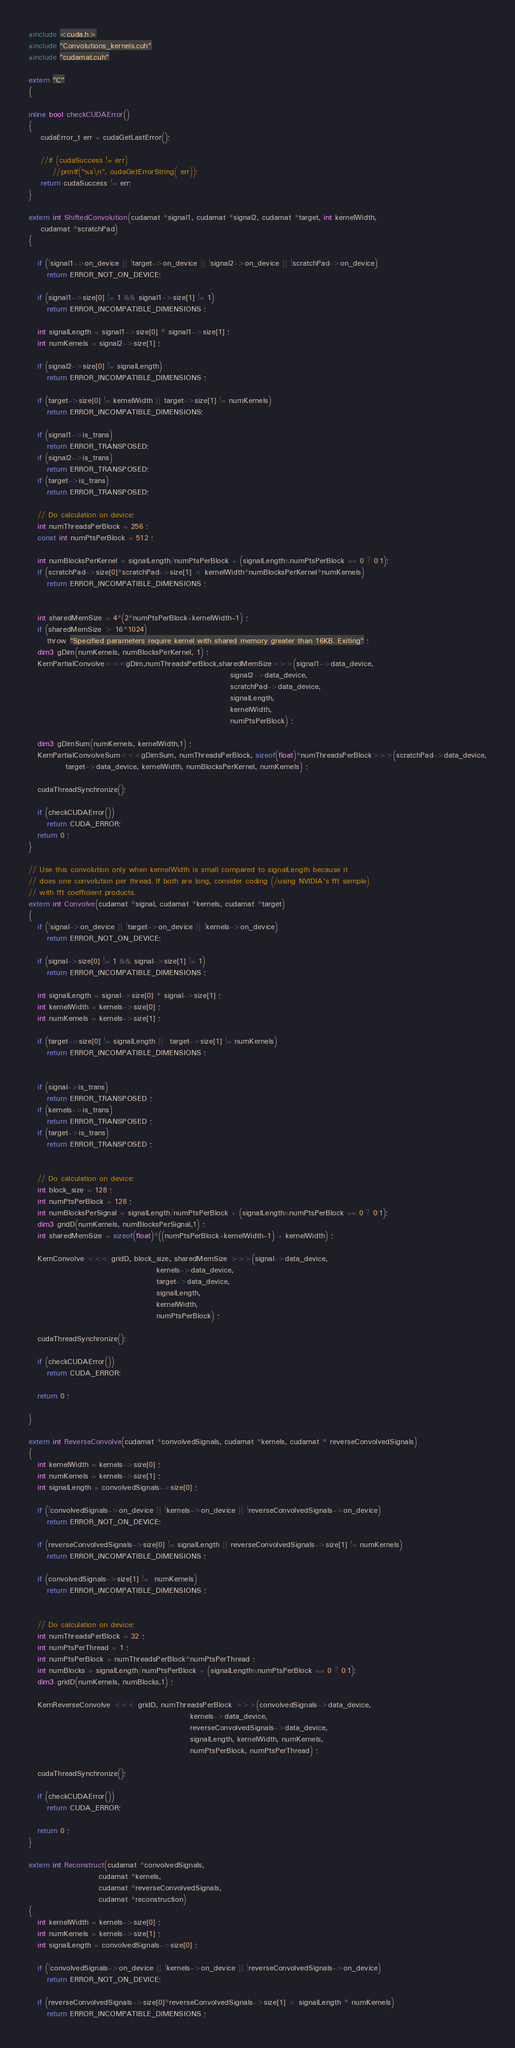<code> <loc_0><loc_0><loc_500><loc_500><_Cuda_>#include <cuda.h>  
#include "Convolutions_kernels.cuh"
#include "cudamat.cuh" 

extern "C" 
{

inline bool checkCUDAError() 
{
    cudaError_t err = cudaGetLastError();

    //if (cudaSuccess != err)
        //printf("%s\n", cudaGetErrorString( err));
    return cudaSuccess != err;
}

extern int ShiftedConvolution(cudamat *signal1, cudamat *signal2, cudamat *target, int kernelWidth, 
    cudamat *scratchPad)
{

   if (!signal1->on_device || !target->on_device || !signal2->on_device || !scratchPad->on_device)
      return ERROR_NOT_ON_DEVICE;

   if (signal1->size[0] != 1 && signal1->size[1] != 1)
      return ERROR_INCOMPATIBLE_DIMENSIONS ;

   int signalLength = signal1->size[0] * signal1->size[1] ; 
   int numKernels = signal2->size[1] ; 

   if (signal2->size[0] != signalLength)
      return ERROR_INCOMPATIBLE_DIMENSIONS ;

   if (target->size[0] != kernelWidth || target->size[1] != numKernels)
      return ERROR_INCOMPATIBLE_DIMENSIONS;

   if (signal1->is_trans)
      return ERROR_TRANSPOSED;
   if (signal2->is_trans)
      return ERROR_TRANSPOSED;
   if (target->is_trans)
      return ERROR_TRANSPOSED;

   // Do calculation on device:  
   int numThreadsPerBlock = 256 ;  
   const int numPtsPerBlock = 512 ;

   int numBlocksPerKernel = signalLength/numPtsPerBlock + (signalLength%numPtsPerBlock == 0 ? 0:1); 
   if (scratchPad->size[0]*scratchPad->size[1] < kernelWidth*numBlocksPerKernel*numKernels)
      return ERROR_INCOMPATIBLE_DIMENSIONS ;


   int sharedMemSize = 4*(2*numPtsPerBlock+kernelWidth-1) ;
   if (sharedMemSize > 16*1024)
      throw "Specified parameters require kernel with shared memory greater than 16KB. Exiting" ; 
   dim3 gDim(numKernels, numBlocksPerKernel, 1) ; 
   KernPartialConvolve<<<gDim,numThreadsPerBlock,sharedMemSize>>>(signal1->data_device, 
                                                                  signal2->data_device, 
                                                                  scratchPad->data_device,
                                                                  signalLength, 
                                                                  kernelWidth, 
                                                                  numPtsPerBlock) ; 

   dim3 gDimSum(numKernels, kernelWidth,1) ; 
   KernPartialConvolveSum<<<gDimSum, numThreadsPerBlock, sizeof(float)*numThreadsPerBlock>>>(scratchPad->data_device,
			target->data_device, kernelWidth, numBlocksPerKernel, numKernels) ; 

   cudaThreadSynchronize();

   if (checkCUDAError())
      return CUDA_ERROR;
   return 0 ; 
}

// Use this convolution only when kernelWidth is small compared to signalLength because it 
// does one convolution per thread. If both are long, consider coding (/using NVIDIA's fft sample)
// with fft coefficient products.
extern int Convolve(cudamat *signal, cudamat *kernels, cudamat *target)
{
   if (!signal->on_device || !target->on_device || !kernels->on_device)
      return ERROR_NOT_ON_DEVICE;

   if (signal->size[0] != 1 && signal->size[1] != 1)
      return ERROR_INCOMPATIBLE_DIMENSIONS ;

   int signalLength = signal->size[0] * signal->size[1] ;
   int kernelWidth = kernels->size[0] ; 
   int numKernels = kernels->size[1] ; 

   if (target->size[0] != signalLength ||  target->size[1] != numKernels)
      return ERROR_INCOMPATIBLE_DIMENSIONS ;


   if (signal->is_trans)
      return ERROR_TRANSPOSED ;
   if (kernels->is_trans)
      return ERROR_TRANSPOSED ;
   if (target->is_trans)
      return ERROR_TRANSPOSED ;


   // Do calculation on device:  
   int block_size = 128 ;  
   int numPtsPerBlock = 128 ; 
   int numBlocksPerSignal = signalLength/numPtsPerBlock + (signalLength%numPtsPerBlock == 0 ? 0:1); 
   dim3 gridD(numKernels, numBlocksPerSignal,1) ; 
   int sharedMemSize = sizeof(float)*((numPtsPerBlock+kernelWidth-1) + kernelWidth) ; 

   KernConvolve <<< gridD, block_size, sharedMemSize >>>(signal->data_device, 
                                          kernels->data_device, 
                                          target->data_device, 
                                          signalLength, 
                                          kernelWidth, 
                                          numPtsPerBlock) ; 

   cudaThreadSynchronize();

   if (checkCUDAError())
      return CUDA_ERROR;

   return 0 ; 

}

extern int ReverseConvolve(cudamat *convolvedSignals, cudamat *kernels, cudamat * reverseConvolvedSignals)
{
   int kernelWidth = kernels->size[0] ; 
   int numKernels = kernels->size[1] ; 
   int signalLength = convolvedSignals->size[0] ;

   if (!convolvedSignals->on_device || !kernels->on_device || !reverseConvolvedSignals->on_device)
      return ERROR_NOT_ON_DEVICE;

   if (reverseConvolvedSignals->size[0] != signalLength || reverseConvolvedSignals->size[1] != numKernels)
      return ERROR_INCOMPATIBLE_DIMENSIONS ;

   if (convolvedSignals->size[1] !=  numKernels)
      return ERROR_INCOMPATIBLE_DIMENSIONS ;


   // Do calculation on device:  
   int numThreadsPerBlock = 32 ;  
   int numPtsPerThread = 1 ; 
   int numPtsPerBlock = numThreadsPerBlock*numPtsPerThread ; 
   int numBlocks = signalLength/numPtsPerBlock + (signalLength%numPtsPerBlock == 0 ? 0:1); 
   dim3 gridD(numKernels, numBlocks,1) ; 

   KernReverseConvolve <<< gridD, numThreadsPerBlock >>>(convolvedSignals->data_device, 
                                                     kernels->data_device, 
                                                     reverseConvolvedSignals->data_device, 
                                                     signalLength, kernelWidth, numKernels, 
                                                     numPtsPerBlock, numPtsPerThread) ; 

   cudaThreadSynchronize();

   if (checkCUDAError())
      return CUDA_ERROR;

   return 0 ; 
}

extern int Reconstruct(cudamat *convolvedSignals, 
                       cudamat *kernels, 
                       cudamat *reverseConvolvedSignals, 
                       cudamat *reconstruction)
{
   int kernelWidth = kernels->size[0] ; 
   int numKernels = kernels->size[1] ; 
   int signalLength = convolvedSignals->size[0] ;

   if (!convolvedSignals->on_device || !kernels->on_device || !reverseConvolvedSignals->on_device)
      return ERROR_NOT_ON_DEVICE;

   if (reverseConvolvedSignals->size[0]*reverseConvolvedSignals->size[1] < signalLength * numKernels)
      return ERROR_INCOMPATIBLE_DIMENSIONS ;</code> 